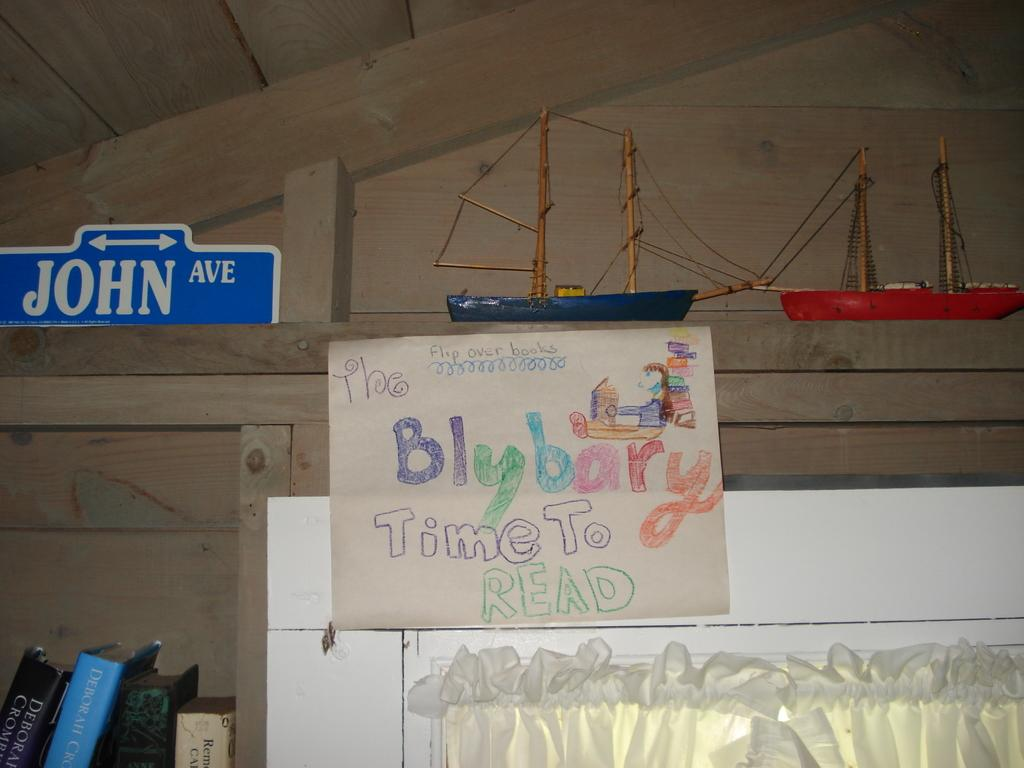<image>
Give a short and clear explanation of the subsequent image. A sign that says The Blybary time to read with a blue and red sail boat above it. 